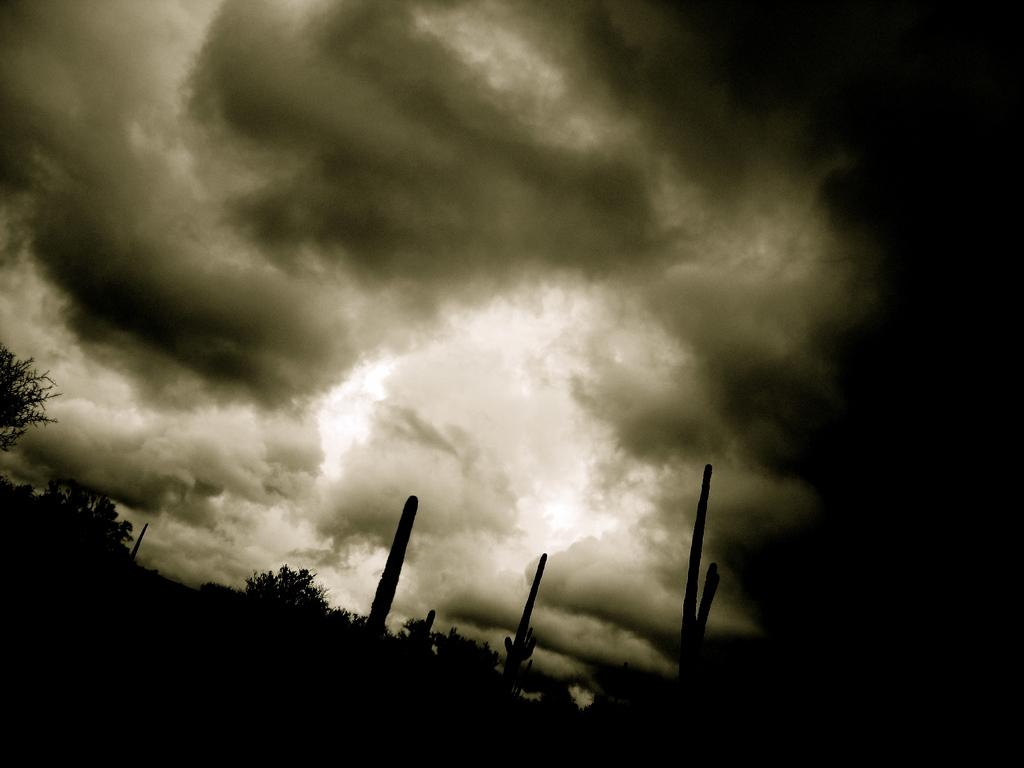What is the color of the bottom part of the image? The bottom of the image is dark. What type of natural elements can be seen in the image? There are trees visible in the image. What else can be seen in the image besides trees? There are objects visible in the image. What is visible in the sky in the background of the image? There are clouds in the sky in the background of the image. Can you see a flame coming from the trees in the image? There is no flame visible in the image, as it only features trees and clouds in the sky. 